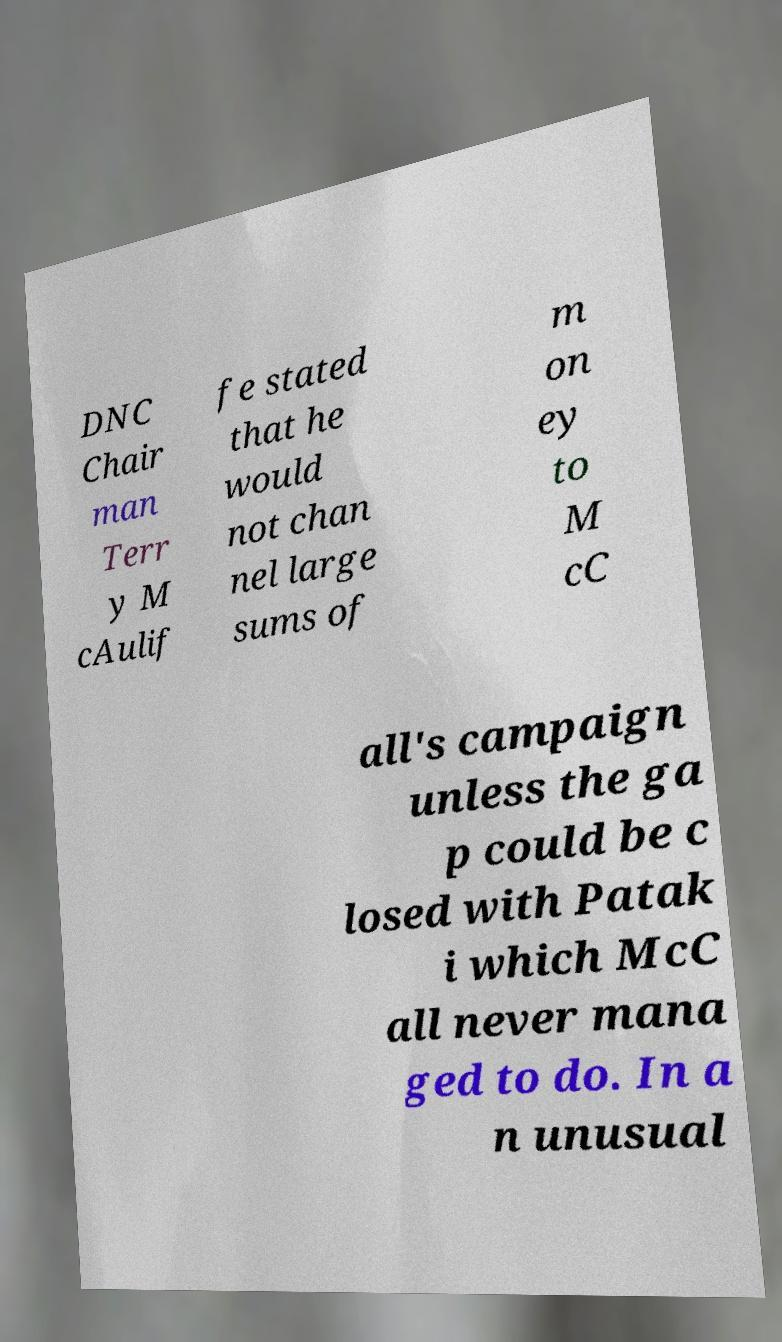For documentation purposes, I need the text within this image transcribed. Could you provide that? DNC Chair man Terr y M cAulif fe stated that he would not chan nel large sums of m on ey to M cC all's campaign unless the ga p could be c losed with Patak i which McC all never mana ged to do. In a n unusual 